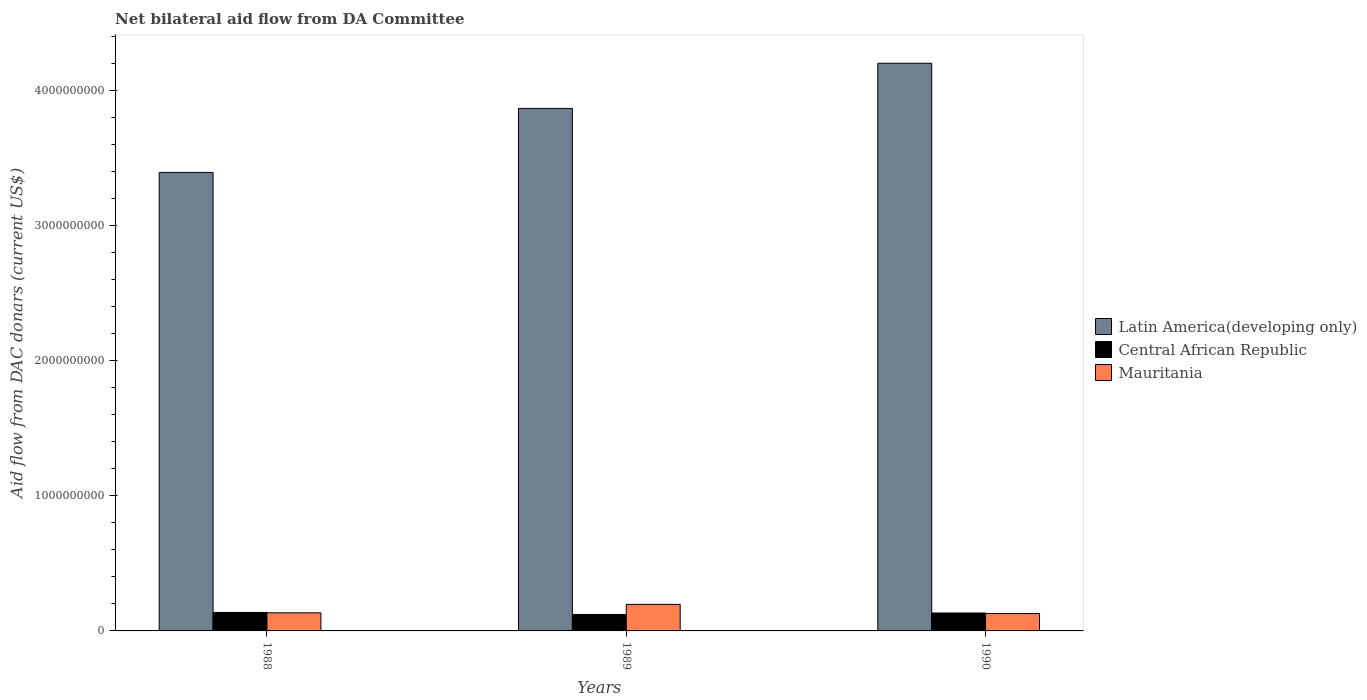How many different coloured bars are there?
Provide a short and direct response. 3. Are the number of bars per tick equal to the number of legend labels?
Keep it short and to the point. Yes. How many bars are there on the 2nd tick from the left?
Offer a very short reply. 3. In how many cases, is the number of bars for a given year not equal to the number of legend labels?
Your answer should be very brief. 0. What is the aid flow in in Latin America(developing only) in 1988?
Keep it short and to the point. 3.40e+09. Across all years, what is the maximum aid flow in in Central African Republic?
Provide a succinct answer. 1.37e+08. Across all years, what is the minimum aid flow in in Latin America(developing only)?
Give a very brief answer. 3.40e+09. In which year was the aid flow in in Latin America(developing only) minimum?
Offer a terse response. 1988. What is the total aid flow in in Latin America(developing only) in the graph?
Ensure brevity in your answer.  1.15e+1. What is the difference between the aid flow in in Central African Republic in 1988 and that in 1989?
Ensure brevity in your answer.  1.47e+07. What is the difference between the aid flow in in Mauritania in 1989 and the aid flow in in Central African Republic in 1990?
Make the answer very short. 6.37e+07. What is the average aid flow in in Latin America(developing only) per year?
Offer a terse response. 3.82e+09. In the year 1990, what is the difference between the aid flow in in Latin America(developing only) and aid flow in in Mauritania?
Provide a short and direct response. 4.08e+09. In how many years, is the aid flow in in Central African Republic greater than 200000000 US$?
Ensure brevity in your answer.  0. What is the ratio of the aid flow in in Mauritania in 1989 to that in 1990?
Provide a succinct answer. 1.53. What is the difference between the highest and the second highest aid flow in in Central African Republic?
Give a very brief answer. 4.06e+06. What is the difference between the highest and the lowest aid flow in in Mauritania?
Your response must be concise. 6.77e+07. What does the 2nd bar from the left in 1988 represents?
Offer a terse response. Central African Republic. What does the 2nd bar from the right in 1989 represents?
Offer a terse response. Central African Republic. What is the difference between two consecutive major ticks on the Y-axis?
Provide a short and direct response. 1.00e+09. Does the graph contain grids?
Offer a very short reply. No. How are the legend labels stacked?
Keep it short and to the point. Vertical. What is the title of the graph?
Provide a succinct answer. Net bilateral aid flow from DA Committee. What is the label or title of the X-axis?
Your answer should be compact. Years. What is the label or title of the Y-axis?
Your answer should be compact. Aid flow from DAC donars (current US$). What is the Aid flow from DAC donars (current US$) of Latin America(developing only) in 1988?
Your response must be concise. 3.40e+09. What is the Aid flow from DAC donars (current US$) in Central African Republic in 1988?
Make the answer very short. 1.37e+08. What is the Aid flow from DAC donars (current US$) of Mauritania in 1988?
Keep it short and to the point. 1.34e+08. What is the Aid flow from DAC donars (current US$) of Latin America(developing only) in 1989?
Your answer should be very brief. 3.87e+09. What is the Aid flow from DAC donars (current US$) of Central African Republic in 1989?
Provide a short and direct response. 1.22e+08. What is the Aid flow from DAC donars (current US$) of Mauritania in 1989?
Your response must be concise. 1.96e+08. What is the Aid flow from DAC donars (current US$) in Latin America(developing only) in 1990?
Your answer should be compact. 4.20e+09. What is the Aid flow from DAC donars (current US$) in Central African Republic in 1990?
Make the answer very short. 1.33e+08. What is the Aid flow from DAC donars (current US$) of Mauritania in 1990?
Your answer should be very brief. 1.29e+08. Across all years, what is the maximum Aid flow from DAC donars (current US$) of Latin America(developing only)?
Your answer should be compact. 4.20e+09. Across all years, what is the maximum Aid flow from DAC donars (current US$) of Central African Republic?
Give a very brief answer. 1.37e+08. Across all years, what is the maximum Aid flow from DAC donars (current US$) in Mauritania?
Give a very brief answer. 1.96e+08. Across all years, what is the minimum Aid flow from DAC donars (current US$) of Latin America(developing only)?
Offer a terse response. 3.40e+09. Across all years, what is the minimum Aid flow from DAC donars (current US$) of Central African Republic?
Provide a succinct answer. 1.22e+08. Across all years, what is the minimum Aid flow from DAC donars (current US$) in Mauritania?
Keep it short and to the point. 1.29e+08. What is the total Aid flow from DAC donars (current US$) in Latin America(developing only) in the graph?
Make the answer very short. 1.15e+1. What is the total Aid flow from DAC donars (current US$) of Central African Republic in the graph?
Give a very brief answer. 3.92e+08. What is the total Aid flow from DAC donars (current US$) in Mauritania in the graph?
Ensure brevity in your answer.  4.59e+08. What is the difference between the Aid flow from DAC donars (current US$) in Latin America(developing only) in 1988 and that in 1989?
Provide a succinct answer. -4.74e+08. What is the difference between the Aid flow from DAC donars (current US$) of Central African Republic in 1988 and that in 1989?
Make the answer very short. 1.47e+07. What is the difference between the Aid flow from DAC donars (current US$) in Mauritania in 1988 and that in 1989?
Ensure brevity in your answer.  -6.26e+07. What is the difference between the Aid flow from DAC donars (current US$) of Latin America(developing only) in 1988 and that in 1990?
Make the answer very short. -8.09e+08. What is the difference between the Aid flow from DAC donars (current US$) of Central African Republic in 1988 and that in 1990?
Your answer should be compact. 4.06e+06. What is the difference between the Aid flow from DAC donars (current US$) of Mauritania in 1988 and that in 1990?
Offer a terse response. 5.06e+06. What is the difference between the Aid flow from DAC donars (current US$) of Latin America(developing only) in 1989 and that in 1990?
Your answer should be very brief. -3.35e+08. What is the difference between the Aid flow from DAC donars (current US$) of Central African Republic in 1989 and that in 1990?
Your answer should be compact. -1.06e+07. What is the difference between the Aid flow from DAC donars (current US$) of Mauritania in 1989 and that in 1990?
Make the answer very short. 6.77e+07. What is the difference between the Aid flow from DAC donars (current US$) in Latin America(developing only) in 1988 and the Aid flow from DAC donars (current US$) in Central African Republic in 1989?
Give a very brief answer. 3.27e+09. What is the difference between the Aid flow from DAC donars (current US$) of Latin America(developing only) in 1988 and the Aid flow from DAC donars (current US$) of Mauritania in 1989?
Provide a short and direct response. 3.20e+09. What is the difference between the Aid flow from DAC donars (current US$) in Central African Republic in 1988 and the Aid flow from DAC donars (current US$) in Mauritania in 1989?
Provide a short and direct response. -5.97e+07. What is the difference between the Aid flow from DAC donars (current US$) of Latin America(developing only) in 1988 and the Aid flow from DAC donars (current US$) of Central African Republic in 1990?
Give a very brief answer. 3.26e+09. What is the difference between the Aid flow from DAC donars (current US$) of Latin America(developing only) in 1988 and the Aid flow from DAC donars (current US$) of Mauritania in 1990?
Provide a succinct answer. 3.27e+09. What is the difference between the Aid flow from DAC donars (current US$) of Latin America(developing only) in 1989 and the Aid flow from DAC donars (current US$) of Central African Republic in 1990?
Your answer should be very brief. 3.74e+09. What is the difference between the Aid flow from DAC donars (current US$) in Latin America(developing only) in 1989 and the Aid flow from DAC donars (current US$) in Mauritania in 1990?
Your answer should be very brief. 3.74e+09. What is the difference between the Aid flow from DAC donars (current US$) of Central African Republic in 1989 and the Aid flow from DAC donars (current US$) of Mauritania in 1990?
Give a very brief answer. -6.68e+06. What is the average Aid flow from DAC donars (current US$) of Latin America(developing only) per year?
Your response must be concise. 3.82e+09. What is the average Aid flow from DAC donars (current US$) of Central African Republic per year?
Provide a short and direct response. 1.31e+08. What is the average Aid flow from DAC donars (current US$) in Mauritania per year?
Make the answer very short. 1.53e+08. In the year 1988, what is the difference between the Aid flow from DAC donars (current US$) of Latin America(developing only) and Aid flow from DAC donars (current US$) of Central African Republic?
Offer a very short reply. 3.26e+09. In the year 1988, what is the difference between the Aid flow from DAC donars (current US$) of Latin America(developing only) and Aid flow from DAC donars (current US$) of Mauritania?
Keep it short and to the point. 3.26e+09. In the year 1988, what is the difference between the Aid flow from DAC donars (current US$) of Central African Republic and Aid flow from DAC donars (current US$) of Mauritania?
Offer a terse response. 2.94e+06. In the year 1989, what is the difference between the Aid flow from DAC donars (current US$) of Latin America(developing only) and Aid flow from DAC donars (current US$) of Central African Republic?
Offer a very short reply. 3.75e+09. In the year 1989, what is the difference between the Aid flow from DAC donars (current US$) in Latin America(developing only) and Aid flow from DAC donars (current US$) in Mauritania?
Ensure brevity in your answer.  3.67e+09. In the year 1989, what is the difference between the Aid flow from DAC donars (current US$) in Central African Republic and Aid flow from DAC donars (current US$) in Mauritania?
Your answer should be very brief. -7.44e+07. In the year 1990, what is the difference between the Aid flow from DAC donars (current US$) in Latin America(developing only) and Aid flow from DAC donars (current US$) in Central African Republic?
Keep it short and to the point. 4.07e+09. In the year 1990, what is the difference between the Aid flow from DAC donars (current US$) of Latin America(developing only) and Aid flow from DAC donars (current US$) of Mauritania?
Ensure brevity in your answer.  4.08e+09. In the year 1990, what is the difference between the Aid flow from DAC donars (current US$) in Central African Republic and Aid flow from DAC donars (current US$) in Mauritania?
Your answer should be very brief. 3.94e+06. What is the ratio of the Aid flow from DAC donars (current US$) of Latin America(developing only) in 1988 to that in 1989?
Your answer should be very brief. 0.88. What is the ratio of the Aid flow from DAC donars (current US$) in Central African Republic in 1988 to that in 1989?
Your answer should be very brief. 1.12. What is the ratio of the Aid flow from DAC donars (current US$) of Mauritania in 1988 to that in 1989?
Offer a very short reply. 0.68. What is the ratio of the Aid flow from DAC donars (current US$) of Latin America(developing only) in 1988 to that in 1990?
Offer a terse response. 0.81. What is the ratio of the Aid flow from DAC donars (current US$) in Central African Republic in 1988 to that in 1990?
Ensure brevity in your answer.  1.03. What is the ratio of the Aid flow from DAC donars (current US$) in Mauritania in 1988 to that in 1990?
Offer a very short reply. 1.04. What is the ratio of the Aid flow from DAC donars (current US$) of Latin America(developing only) in 1989 to that in 1990?
Offer a terse response. 0.92. What is the ratio of the Aid flow from DAC donars (current US$) of Mauritania in 1989 to that in 1990?
Offer a very short reply. 1.53. What is the difference between the highest and the second highest Aid flow from DAC donars (current US$) in Latin America(developing only)?
Ensure brevity in your answer.  3.35e+08. What is the difference between the highest and the second highest Aid flow from DAC donars (current US$) in Central African Republic?
Give a very brief answer. 4.06e+06. What is the difference between the highest and the second highest Aid flow from DAC donars (current US$) in Mauritania?
Keep it short and to the point. 6.26e+07. What is the difference between the highest and the lowest Aid flow from DAC donars (current US$) in Latin America(developing only)?
Your response must be concise. 8.09e+08. What is the difference between the highest and the lowest Aid flow from DAC donars (current US$) in Central African Republic?
Provide a short and direct response. 1.47e+07. What is the difference between the highest and the lowest Aid flow from DAC donars (current US$) in Mauritania?
Keep it short and to the point. 6.77e+07. 